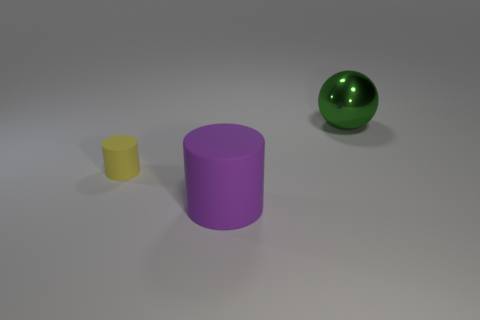Add 2 large green balls. How many objects exist? 5 Subtract all yellow cylinders. How many cylinders are left? 1 Subtract all green cylinders. Subtract all blue balls. How many cylinders are left? 2 Subtract all gray blocks. How many purple cylinders are left? 1 Subtract all big purple rubber cylinders. Subtract all large matte things. How many objects are left? 1 Add 1 yellow matte objects. How many yellow matte objects are left? 2 Add 2 purple cylinders. How many purple cylinders exist? 3 Subtract 1 purple cylinders. How many objects are left? 2 Subtract all cylinders. How many objects are left? 1 